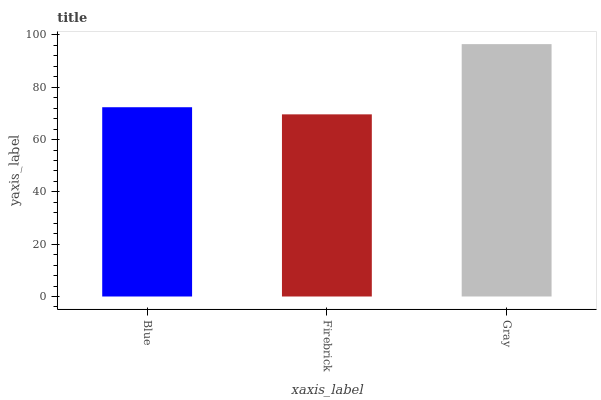Is Firebrick the minimum?
Answer yes or no. Yes. Is Gray the maximum?
Answer yes or no. Yes. Is Gray the minimum?
Answer yes or no. No. Is Firebrick the maximum?
Answer yes or no. No. Is Gray greater than Firebrick?
Answer yes or no. Yes. Is Firebrick less than Gray?
Answer yes or no. Yes. Is Firebrick greater than Gray?
Answer yes or no. No. Is Gray less than Firebrick?
Answer yes or no. No. Is Blue the high median?
Answer yes or no. Yes. Is Blue the low median?
Answer yes or no. Yes. Is Firebrick the high median?
Answer yes or no. No. Is Gray the low median?
Answer yes or no. No. 